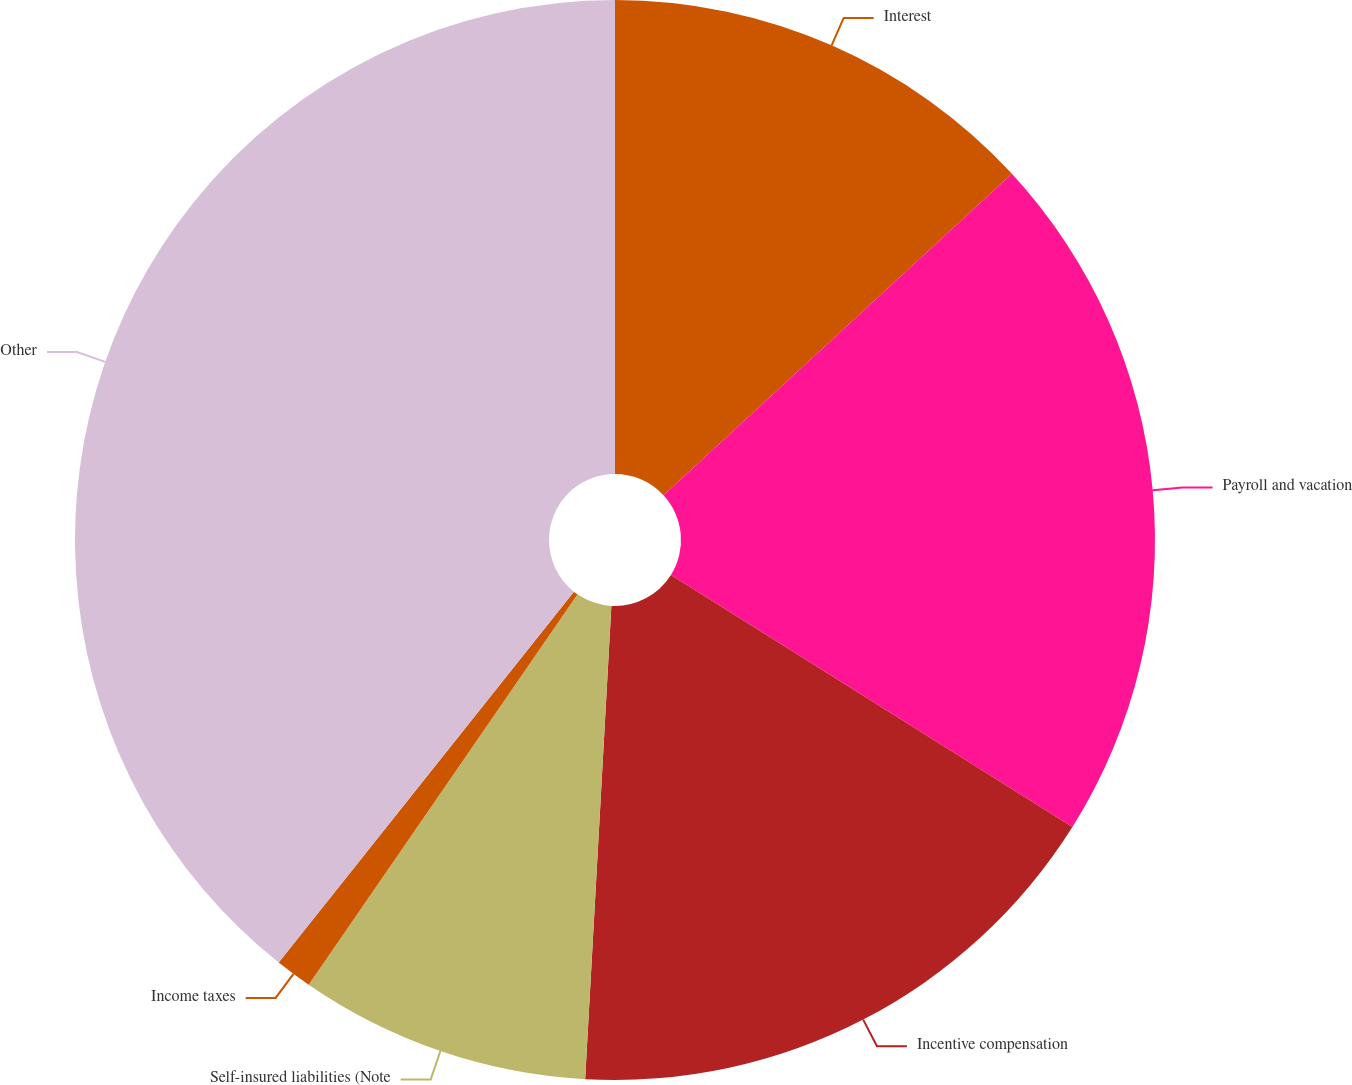Convert chart to OTSL. <chart><loc_0><loc_0><loc_500><loc_500><pie_chart><fcel>Interest<fcel>Payroll and vacation<fcel>Incentive compensation<fcel>Self-insured liabilities (Note<fcel>Income taxes<fcel>Other<nl><fcel>13.14%<fcel>20.78%<fcel>16.96%<fcel>8.72%<fcel>1.1%<fcel>39.3%<nl></chart> 